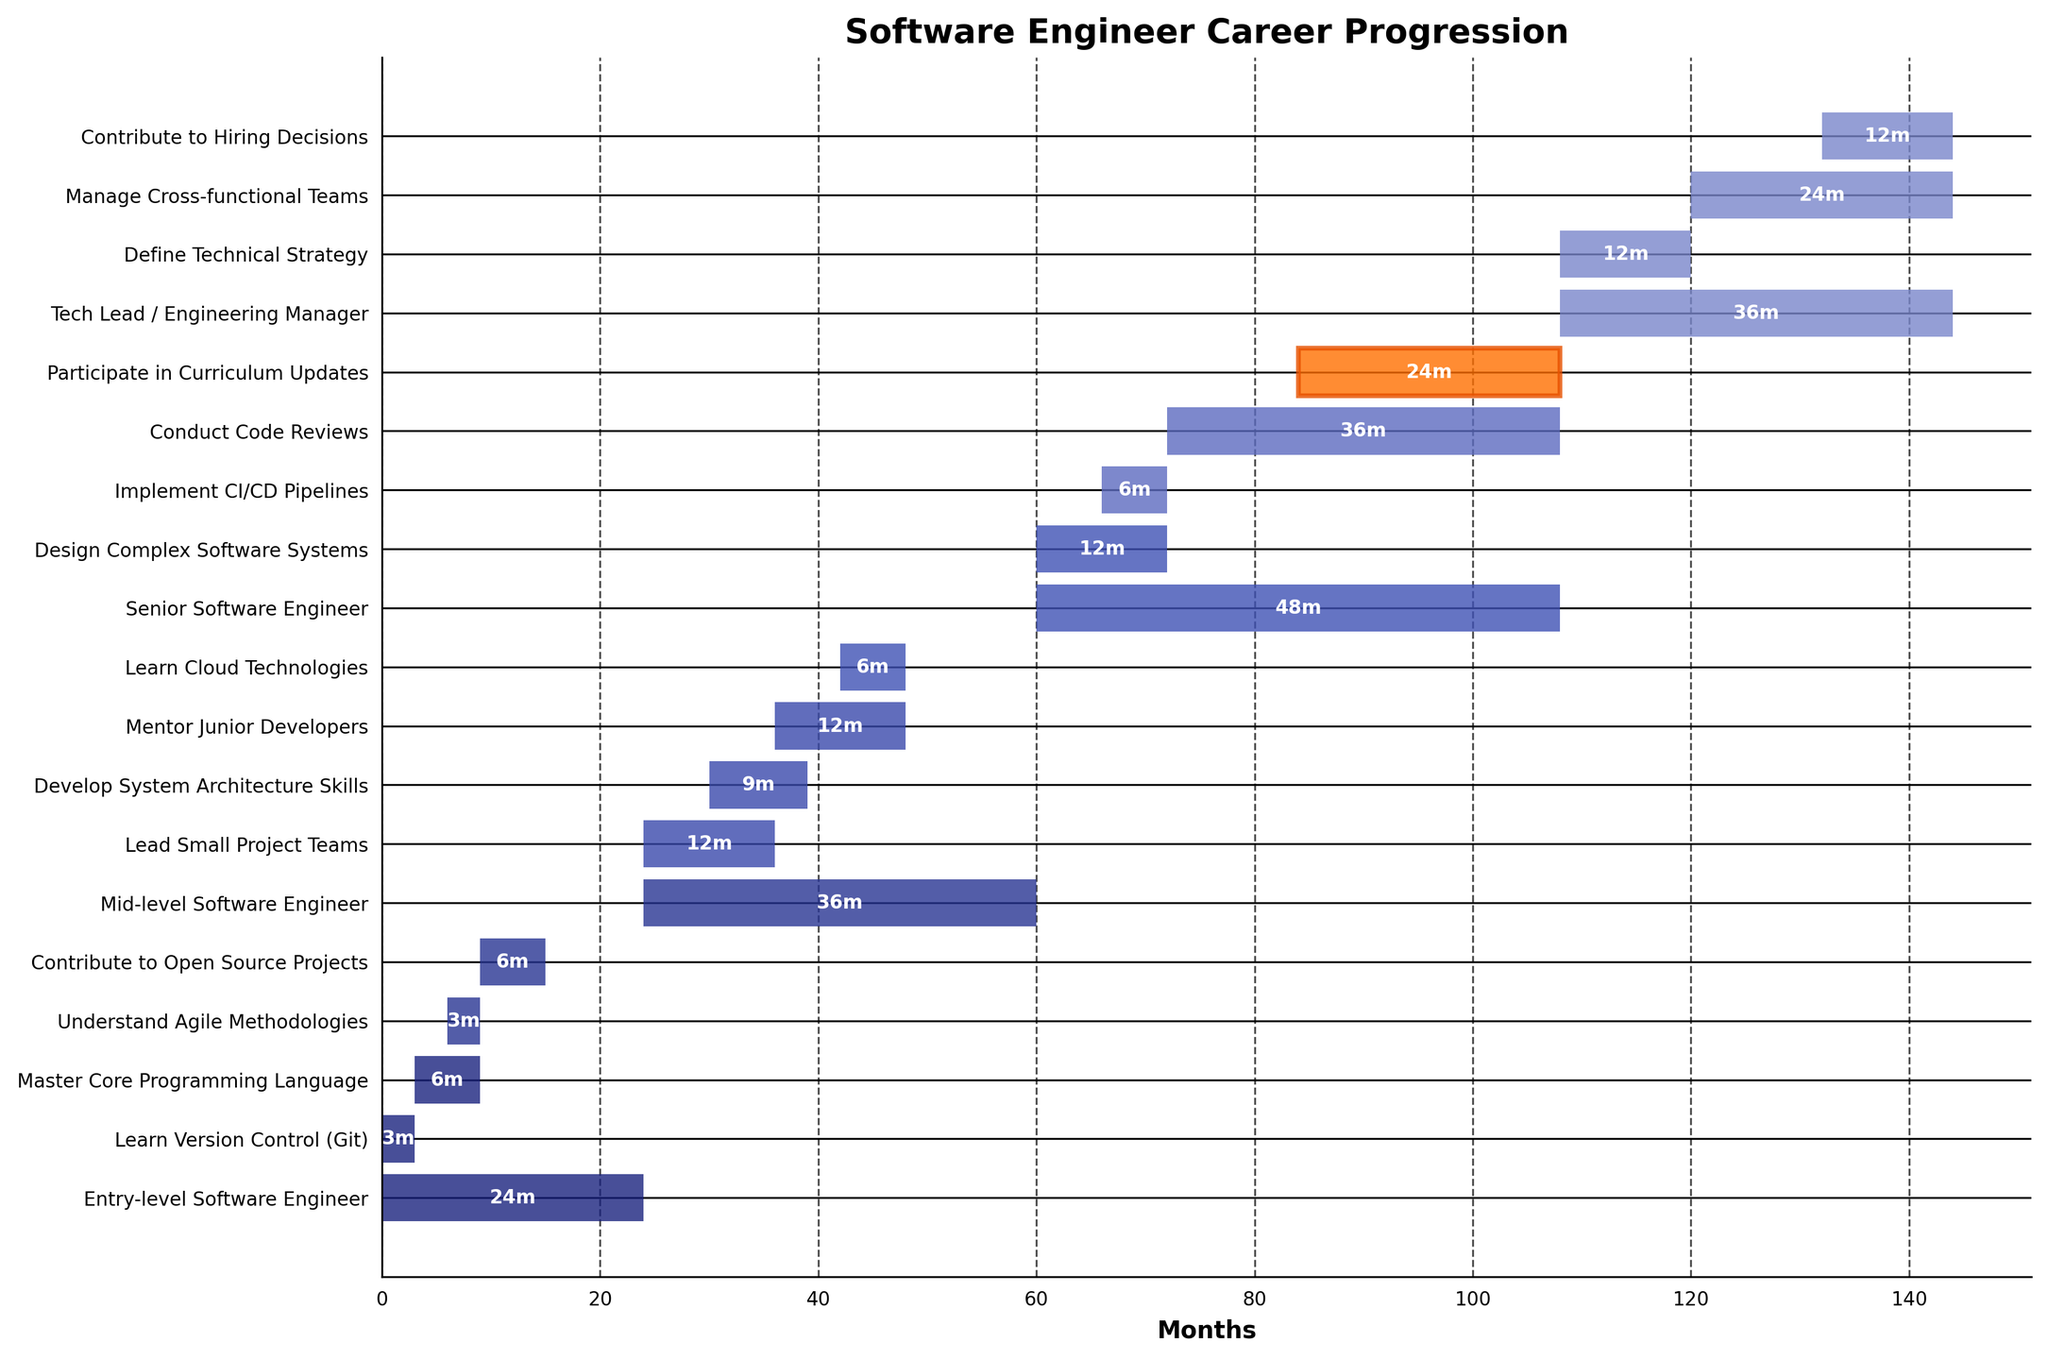What is the duration of the 'Lead Small Project Teams' task? Refer to the bar labeled 'Lead Small Project Teams' and observe the length of the bar. The figure shows it lasts for 12 months.
Answer: 12 months What is the title of the chart? Look at the top of the chart to find the title. The title is 'Software Engineer Career Progression'.
Answer: Software Engineer Career Progression Which task starts first in the career progression? Identify the bars that start at month 0. The tasks 'Entry-level Software Engineer' and 'Learn Version Control (Git)' both start at month 0.
Answer: Learn Version Control (Git) and Entry-level Software Engineer How long does it take for a software engineer to start participating in curriculum updates? Locate the task 'Participate in Curriculum Updates' and observe when it begins. It starts at month 84.
Answer: 84 months Which task has the shortest duration? Compare the lengths of all the bars. The 'Implement CI/CD Pipelines' task, lasting 6 months, is the shortest.
Answer: Implement CI/CD Pipelines What is the total duration for the 'Mid-level Software Engineer' role, and how does it compare to the 'Senior Software Engineer' role? Sum the durations of sub-tasks within each role. 'Mid-level Software Engineer' lasts 36 months (12 + 9 + 12 + 6), while 'Senior Software Engineer' lasts 48 months (12 + 6 + 36 + 24).
Answer: Mid-level: 36 months, Senior: 48 months How many tasks are performed during the 'Tech Lead / Engineering Manager' stage? Count the number of bars that fall under the 'Tech Lead / Engineering Manager' role. There are three tasks: 'Define Technical Strategy', 'Manage Cross-functional Teams', and 'Contribute to Hiring Decisions'.
Answer: 3 tasks What is the cumulative duration of all tasks before reaching 'Tech Lead / Engineering Manager' stage? Add the start times of the three phases before 'Tech Lead / Engineering Manager': 'Entry-level' (24 months) + 'Mid-level' (36 months) + 'Senior' (48 months) = 108 months.
Answer: 108 months Which stage has 'Mentor Junior Developers' as a task, and what does this suggest about the importance of mentorship? Locate the 'Mentor Junior Developers' task under the 'Mid-level Software Engineer' stage. This highlights the significance of mentorship at the mid-level stage.
Answer: Mid-level Software Engineer What color is used to highlight the task 'Participate in Curriculum Updates', and what might this indicate? Observe the bar for 'Participate in Curriculum Updates' and note its distinct color, an orange shade, indicating its particular importance.
Answer: Orange shade 